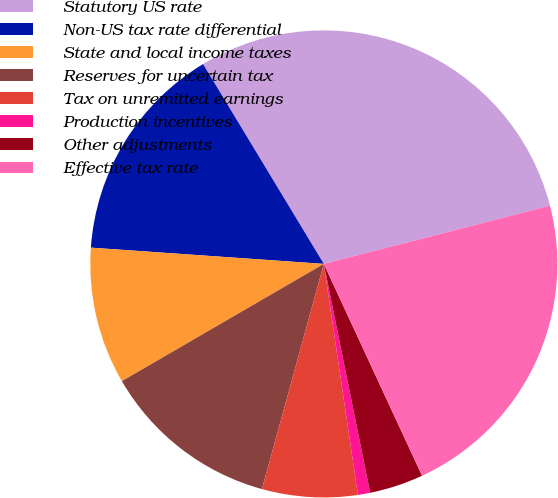<chart> <loc_0><loc_0><loc_500><loc_500><pie_chart><fcel>Statutory US rate<fcel>Non-US tax rate differential<fcel>State and local income taxes<fcel>Reserves for uncertain tax<fcel>Tax on unremitted earnings<fcel>Production incentives<fcel>Other adjustments<fcel>Effective tax rate<nl><fcel>29.64%<fcel>15.24%<fcel>9.48%<fcel>12.36%<fcel>6.6%<fcel>0.85%<fcel>3.73%<fcel>22.1%<nl></chart> 